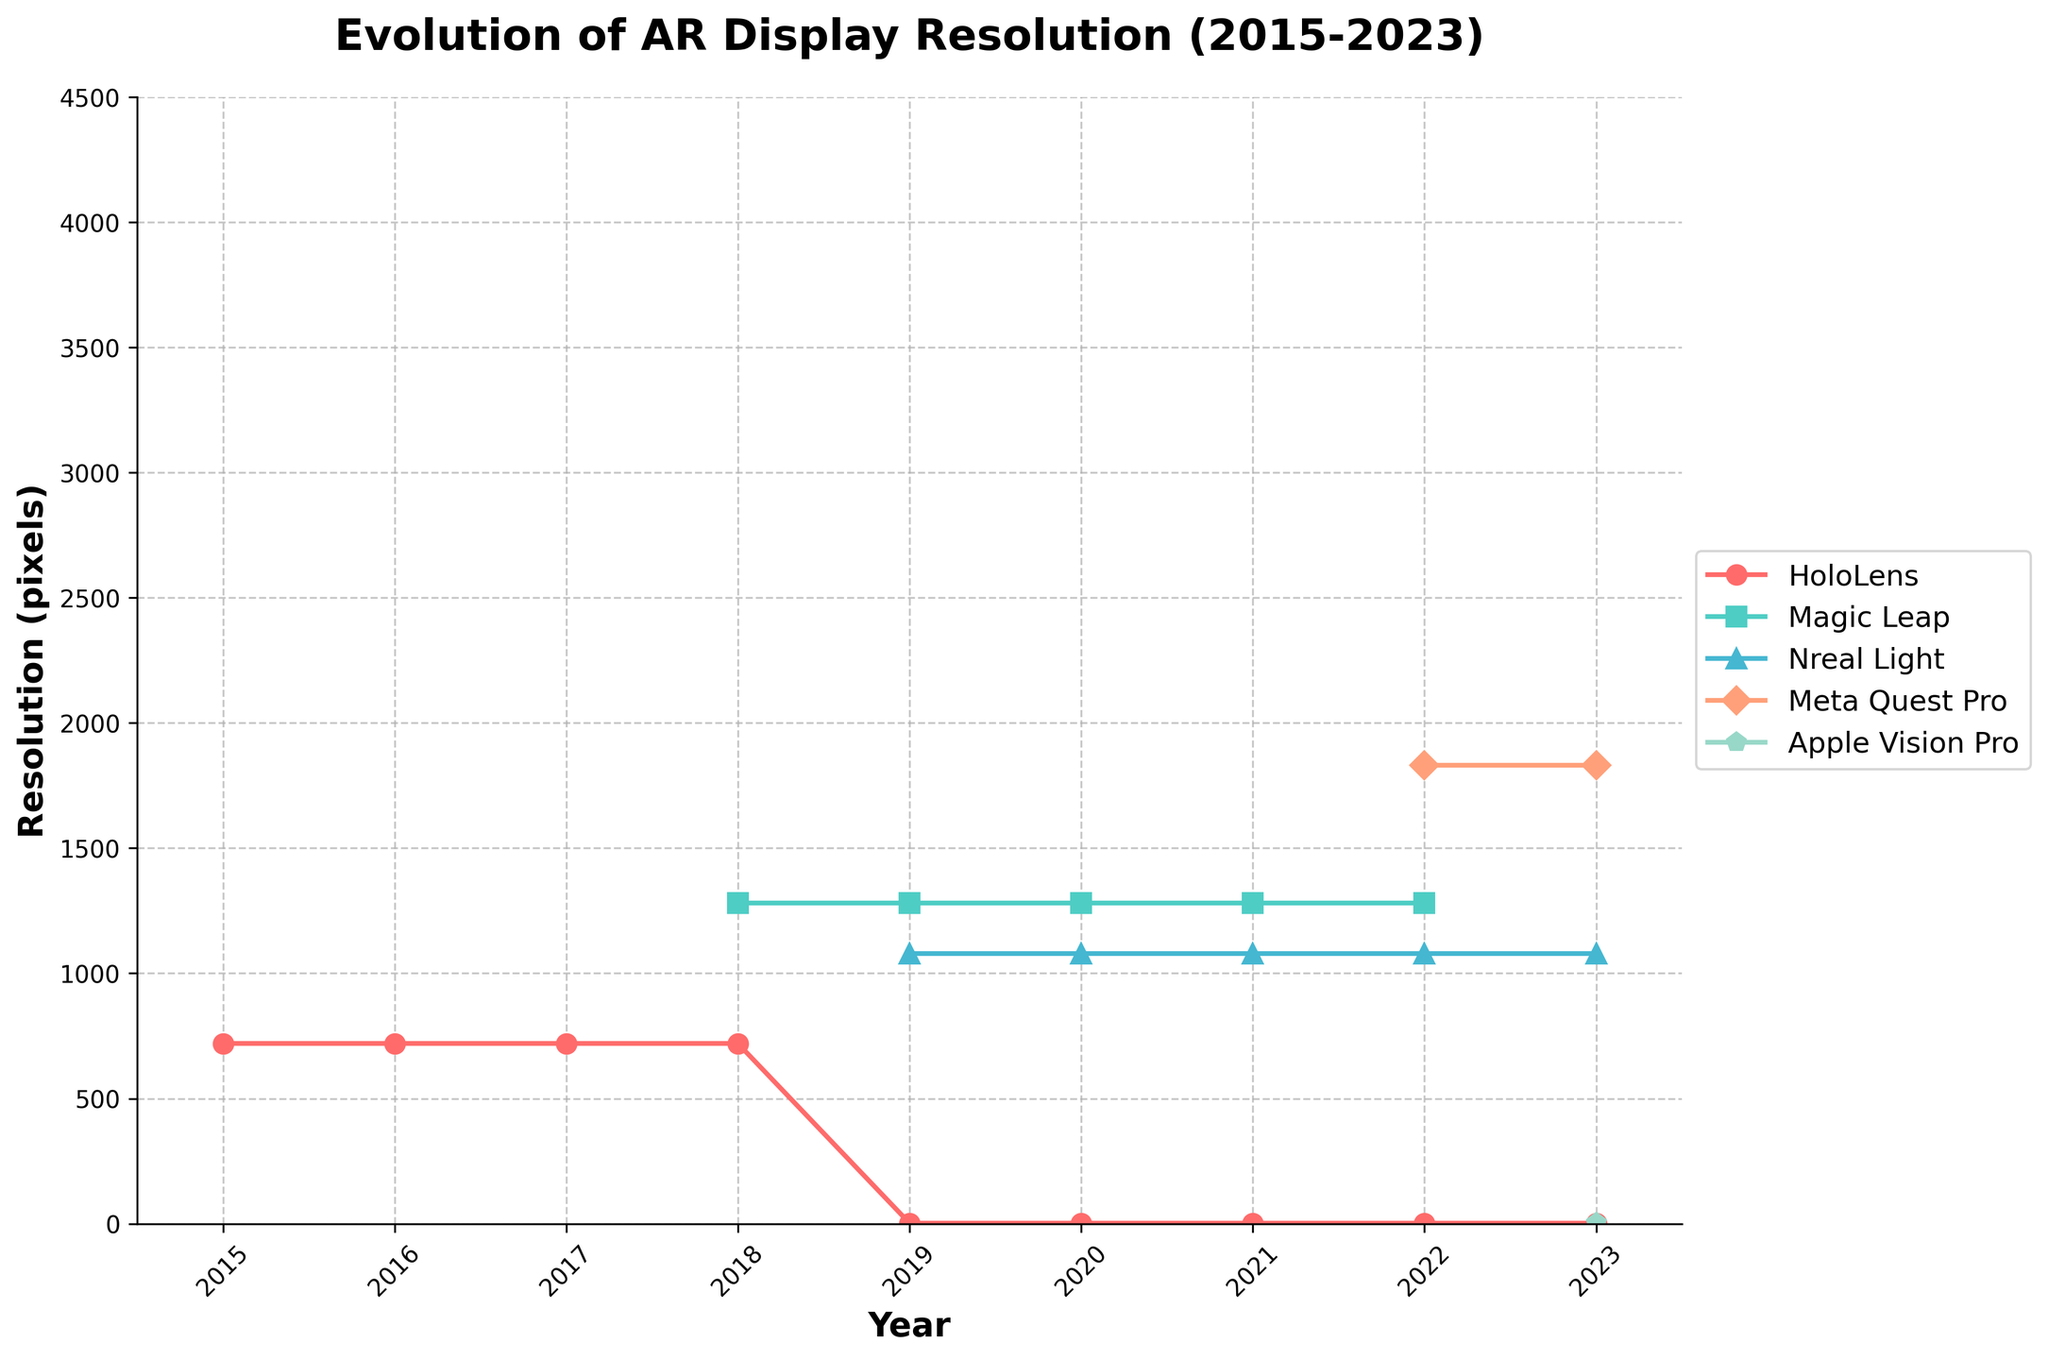Which AR headset had the highest resolution in 2023? Check the data points for the year 2023, identify the highest resolution value, which is 4K, and locate the corresponding headset, which is Apple Vision Pro.
Answer: Apple Vision Pro Between 2018 and 2019, which headset had the largest increase in resolution? Compare resolutions from 2018 to 2019 for each headset. HoloLens moved from 720p to 2K, which is a larger increase compared to others.
Answer: HoloLens What is the average resolution of Magic Leap's headset from 2018 to 2021? Extract resolutions for Magic Leap from 2018 to 2021 (1280x960 each year), calculate the average by summing them and dividing by the number of years (4).
Answer: 1280x960 How does the resolution improvement of Meta Quest Pro between 2022 and 2023 compare to Nreal Light from 2019 to 2020? Meta Quest Pro improved from 1832x1920 to the same resolution, showing no change, while Nreal Light remained at 1080p.
Answer: Meta Quest Pro: No change, Nreal Light: No change Which headset had no changes in resolution from its release up to 2023? Check for headsets with stable resolution values across all years. Only Nreal Light had no changes from 2019 onward.
Answer: Nreal Light What color represents Nreal Light in the plot, and what is its resolution trend? Identify the color assigned to Nreal Light (green) and observe the resolution trend, which starts from 1080p in 2019 and remains constant.
Answer: Green, constant How does the field of view (FOV) change for HoloLens from 2015 to 2023? Note FOV changes for HoloLens each year: 30° from 2015 to 2017, then switching to 43° from 2019 to 2023 without any further change.
Answer: 30° to 43° 